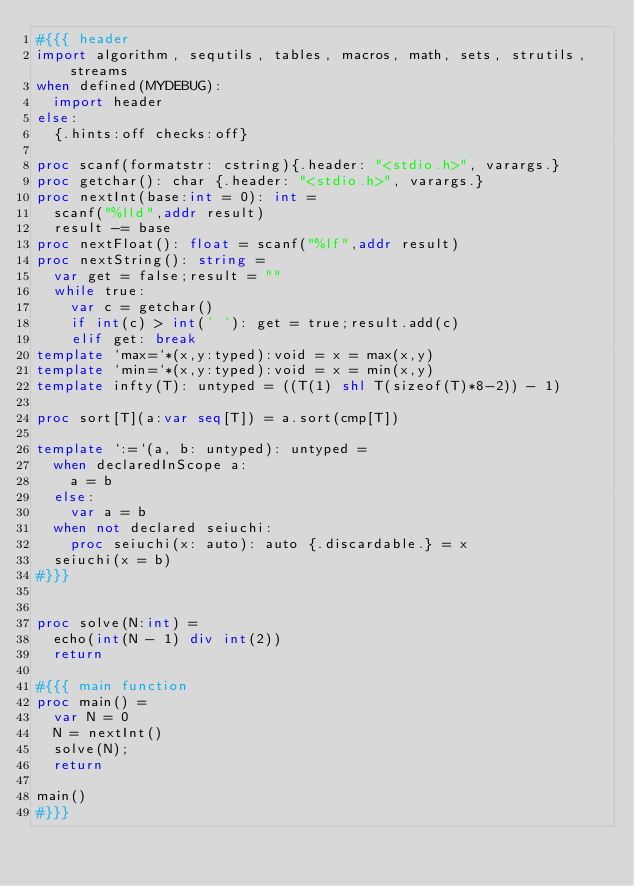<code> <loc_0><loc_0><loc_500><loc_500><_Nim_>#{{{ header
import algorithm, sequtils, tables, macros, math, sets, strutils, streams
when defined(MYDEBUG):
  import header
else:
  {.hints:off checks:off}

proc scanf(formatstr: cstring){.header: "<stdio.h>", varargs.}
proc getchar(): char {.header: "<stdio.h>", varargs.}
proc nextInt(base:int = 0): int =
  scanf("%lld",addr result)
  result -= base
proc nextFloat(): float = scanf("%lf",addr result)
proc nextString(): string =
  var get = false;result = ""
  while true:
    var c = getchar()
    if int(c) > int(' '): get = true;result.add(c)
    elif get: break
template `max=`*(x,y:typed):void = x = max(x,y)
template `min=`*(x,y:typed):void = x = min(x,y)
template infty(T): untyped = ((T(1) shl T(sizeof(T)*8-2)) - 1)

proc sort[T](a:var seq[T]) = a.sort(cmp[T])

template `:=`(a, b: untyped): untyped =
  when declaredInScope a:
    a = b
  else:
    var a = b
  when not declared seiuchi:
    proc seiuchi(x: auto): auto {.discardable.} = x
  seiuchi(x = b)
#}}}


proc solve(N:int) =
  echo(int(N - 1) div int(2))
  return

#{{{ main function
proc main() =
  var N = 0
  N = nextInt()
  solve(N);
  return

main()
#}}}</code> 